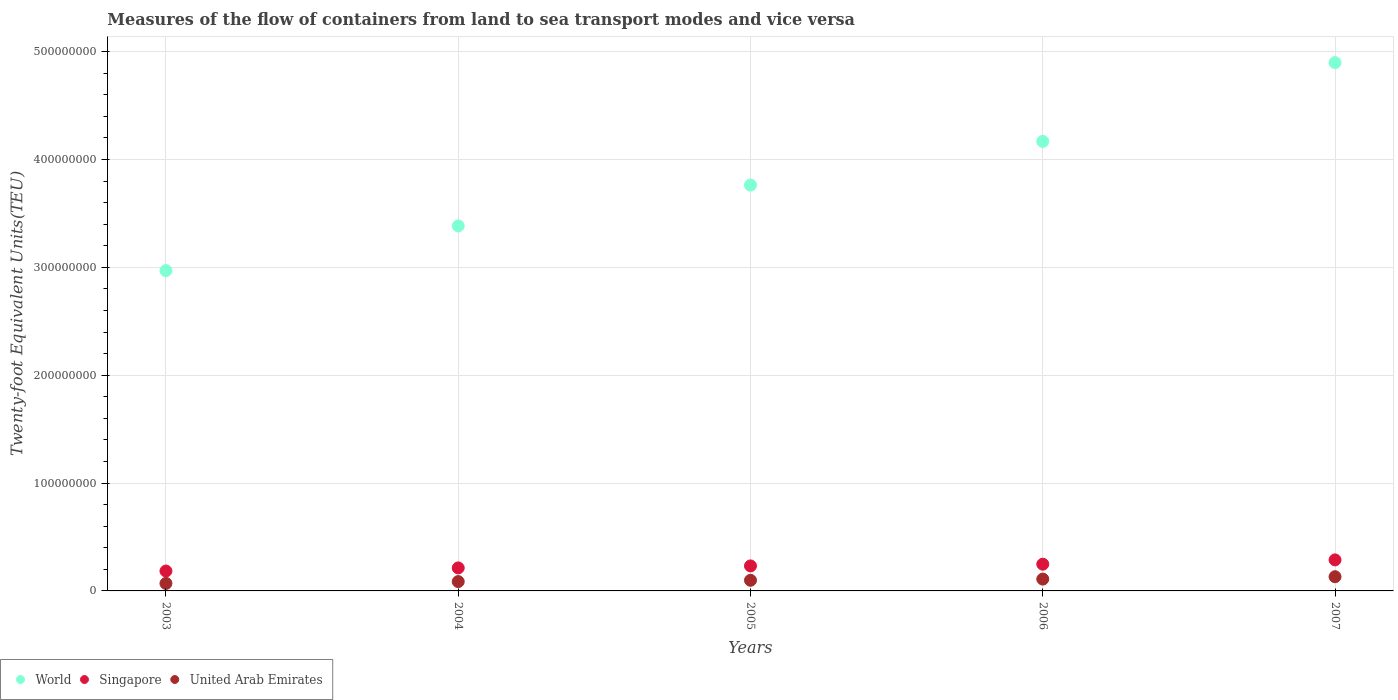Is the number of dotlines equal to the number of legend labels?
Make the answer very short. Yes. What is the container port traffic in World in 2006?
Make the answer very short. 4.17e+08. Across all years, what is the maximum container port traffic in Singapore?
Your response must be concise. 2.88e+07. Across all years, what is the minimum container port traffic in Singapore?
Make the answer very short. 1.84e+07. What is the total container port traffic in Singapore in the graph?
Your answer should be very brief. 1.17e+08. What is the difference between the container port traffic in World in 2004 and that in 2006?
Keep it short and to the point. -7.83e+07. What is the difference between the container port traffic in United Arab Emirates in 2004 and the container port traffic in World in 2007?
Give a very brief answer. -4.81e+08. What is the average container port traffic in World per year?
Give a very brief answer. 3.84e+08. In the year 2007, what is the difference between the container port traffic in Singapore and container port traffic in World?
Your answer should be very brief. -4.61e+08. What is the ratio of the container port traffic in World in 2004 to that in 2006?
Give a very brief answer. 0.81. What is the difference between the highest and the second highest container port traffic in Singapore?
Give a very brief answer. 3.98e+06. What is the difference between the highest and the lowest container port traffic in World?
Provide a short and direct response. 1.93e+08. In how many years, is the container port traffic in United Arab Emirates greater than the average container port traffic in United Arab Emirates taken over all years?
Make the answer very short. 2. Is the sum of the container port traffic in World in 2003 and 2004 greater than the maximum container port traffic in United Arab Emirates across all years?
Offer a terse response. Yes. Is it the case that in every year, the sum of the container port traffic in World and container port traffic in United Arab Emirates  is greater than the container port traffic in Singapore?
Your answer should be compact. Yes. How many years are there in the graph?
Make the answer very short. 5. Are the values on the major ticks of Y-axis written in scientific E-notation?
Keep it short and to the point. No. How are the legend labels stacked?
Make the answer very short. Horizontal. What is the title of the graph?
Ensure brevity in your answer.  Measures of the flow of containers from land to sea transport modes and vice versa. Does "Cameroon" appear as one of the legend labels in the graph?
Your answer should be very brief. No. What is the label or title of the Y-axis?
Your answer should be very brief. Twenty-foot Equivalent Units(TEU). What is the Twenty-foot Equivalent Units(TEU) in World in 2003?
Make the answer very short. 2.97e+08. What is the Twenty-foot Equivalent Units(TEU) of Singapore in 2003?
Keep it short and to the point. 1.84e+07. What is the Twenty-foot Equivalent Units(TEU) of United Arab Emirates in 2003?
Ensure brevity in your answer.  6.96e+06. What is the Twenty-foot Equivalent Units(TEU) in World in 2004?
Offer a very short reply. 3.38e+08. What is the Twenty-foot Equivalent Units(TEU) in Singapore in 2004?
Keep it short and to the point. 2.13e+07. What is the Twenty-foot Equivalent Units(TEU) in United Arab Emirates in 2004?
Make the answer very short. 8.66e+06. What is the Twenty-foot Equivalent Units(TEU) in World in 2005?
Keep it short and to the point. 3.76e+08. What is the Twenty-foot Equivalent Units(TEU) of Singapore in 2005?
Offer a terse response. 2.32e+07. What is the Twenty-foot Equivalent Units(TEU) of United Arab Emirates in 2005?
Give a very brief answer. 9.85e+06. What is the Twenty-foot Equivalent Units(TEU) of World in 2006?
Offer a very short reply. 4.17e+08. What is the Twenty-foot Equivalent Units(TEU) of Singapore in 2006?
Your answer should be very brief. 2.48e+07. What is the Twenty-foot Equivalent Units(TEU) in United Arab Emirates in 2006?
Provide a succinct answer. 1.10e+07. What is the Twenty-foot Equivalent Units(TEU) in World in 2007?
Ensure brevity in your answer.  4.90e+08. What is the Twenty-foot Equivalent Units(TEU) in Singapore in 2007?
Offer a terse response. 2.88e+07. What is the Twenty-foot Equivalent Units(TEU) of United Arab Emirates in 2007?
Your response must be concise. 1.32e+07. Across all years, what is the maximum Twenty-foot Equivalent Units(TEU) of World?
Make the answer very short. 4.90e+08. Across all years, what is the maximum Twenty-foot Equivalent Units(TEU) in Singapore?
Give a very brief answer. 2.88e+07. Across all years, what is the maximum Twenty-foot Equivalent Units(TEU) of United Arab Emirates?
Offer a very short reply. 1.32e+07. Across all years, what is the minimum Twenty-foot Equivalent Units(TEU) in World?
Provide a succinct answer. 2.97e+08. Across all years, what is the minimum Twenty-foot Equivalent Units(TEU) of Singapore?
Provide a succinct answer. 1.84e+07. Across all years, what is the minimum Twenty-foot Equivalent Units(TEU) in United Arab Emirates?
Make the answer very short. 6.96e+06. What is the total Twenty-foot Equivalent Units(TEU) of World in the graph?
Make the answer very short. 1.92e+09. What is the total Twenty-foot Equivalent Units(TEU) in Singapore in the graph?
Your answer should be compact. 1.17e+08. What is the total Twenty-foot Equivalent Units(TEU) of United Arab Emirates in the graph?
Give a very brief answer. 4.96e+07. What is the difference between the Twenty-foot Equivalent Units(TEU) in World in 2003 and that in 2004?
Provide a short and direct response. -4.14e+07. What is the difference between the Twenty-foot Equivalent Units(TEU) of Singapore in 2003 and that in 2004?
Provide a succinct answer. -2.89e+06. What is the difference between the Twenty-foot Equivalent Units(TEU) in United Arab Emirates in 2003 and that in 2004?
Give a very brief answer. -1.71e+06. What is the difference between the Twenty-foot Equivalent Units(TEU) in World in 2003 and that in 2005?
Your answer should be compact. -7.93e+07. What is the difference between the Twenty-foot Equivalent Units(TEU) in Singapore in 2003 and that in 2005?
Keep it short and to the point. -4.75e+06. What is the difference between the Twenty-foot Equivalent Units(TEU) in United Arab Emirates in 2003 and that in 2005?
Keep it short and to the point. -2.90e+06. What is the difference between the Twenty-foot Equivalent Units(TEU) in World in 2003 and that in 2006?
Your answer should be compact. -1.20e+08. What is the difference between the Twenty-foot Equivalent Units(TEU) of Singapore in 2003 and that in 2006?
Your answer should be very brief. -6.35e+06. What is the difference between the Twenty-foot Equivalent Units(TEU) of United Arab Emirates in 2003 and that in 2006?
Provide a short and direct response. -4.01e+06. What is the difference between the Twenty-foot Equivalent Units(TEU) in World in 2003 and that in 2007?
Offer a very short reply. -1.93e+08. What is the difference between the Twenty-foot Equivalent Units(TEU) in Singapore in 2003 and that in 2007?
Your answer should be very brief. -1.03e+07. What is the difference between the Twenty-foot Equivalent Units(TEU) of United Arab Emirates in 2003 and that in 2007?
Ensure brevity in your answer.  -6.23e+06. What is the difference between the Twenty-foot Equivalent Units(TEU) in World in 2004 and that in 2005?
Offer a very short reply. -3.78e+07. What is the difference between the Twenty-foot Equivalent Units(TEU) in Singapore in 2004 and that in 2005?
Your answer should be compact. -1.86e+06. What is the difference between the Twenty-foot Equivalent Units(TEU) in United Arab Emirates in 2004 and that in 2005?
Make the answer very short. -1.19e+06. What is the difference between the Twenty-foot Equivalent Units(TEU) of World in 2004 and that in 2006?
Keep it short and to the point. -7.83e+07. What is the difference between the Twenty-foot Equivalent Units(TEU) of Singapore in 2004 and that in 2006?
Your answer should be compact. -3.46e+06. What is the difference between the Twenty-foot Equivalent Units(TEU) in United Arab Emirates in 2004 and that in 2006?
Your answer should be very brief. -2.31e+06. What is the difference between the Twenty-foot Equivalent Units(TEU) in World in 2004 and that in 2007?
Give a very brief answer. -1.51e+08. What is the difference between the Twenty-foot Equivalent Units(TEU) of Singapore in 2004 and that in 2007?
Keep it short and to the point. -7.44e+06. What is the difference between the Twenty-foot Equivalent Units(TEU) in United Arab Emirates in 2004 and that in 2007?
Offer a terse response. -4.52e+06. What is the difference between the Twenty-foot Equivalent Units(TEU) of World in 2005 and that in 2006?
Provide a short and direct response. -4.05e+07. What is the difference between the Twenty-foot Equivalent Units(TEU) in Singapore in 2005 and that in 2006?
Your answer should be very brief. -1.60e+06. What is the difference between the Twenty-foot Equivalent Units(TEU) of United Arab Emirates in 2005 and that in 2006?
Provide a short and direct response. -1.12e+06. What is the difference between the Twenty-foot Equivalent Units(TEU) of World in 2005 and that in 2007?
Give a very brief answer. -1.14e+08. What is the difference between the Twenty-foot Equivalent Units(TEU) of Singapore in 2005 and that in 2007?
Provide a short and direct response. -5.58e+06. What is the difference between the Twenty-foot Equivalent Units(TEU) in United Arab Emirates in 2005 and that in 2007?
Give a very brief answer. -3.33e+06. What is the difference between the Twenty-foot Equivalent Units(TEU) in World in 2006 and that in 2007?
Provide a succinct answer. -7.31e+07. What is the difference between the Twenty-foot Equivalent Units(TEU) of Singapore in 2006 and that in 2007?
Offer a very short reply. -3.98e+06. What is the difference between the Twenty-foot Equivalent Units(TEU) of United Arab Emirates in 2006 and that in 2007?
Give a very brief answer. -2.22e+06. What is the difference between the Twenty-foot Equivalent Units(TEU) in World in 2003 and the Twenty-foot Equivalent Units(TEU) in Singapore in 2004?
Offer a terse response. 2.76e+08. What is the difference between the Twenty-foot Equivalent Units(TEU) in World in 2003 and the Twenty-foot Equivalent Units(TEU) in United Arab Emirates in 2004?
Your answer should be very brief. 2.88e+08. What is the difference between the Twenty-foot Equivalent Units(TEU) in Singapore in 2003 and the Twenty-foot Equivalent Units(TEU) in United Arab Emirates in 2004?
Offer a very short reply. 9.78e+06. What is the difference between the Twenty-foot Equivalent Units(TEU) of World in 2003 and the Twenty-foot Equivalent Units(TEU) of Singapore in 2005?
Ensure brevity in your answer.  2.74e+08. What is the difference between the Twenty-foot Equivalent Units(TEU) of World in 2003 and the Twenty-foot Equivalent Units(TEU) of United Arab Emirates in 2005?
Offer a very short reply. 2.87e+08. What is the difference between the Twenty-foot Equivalent Units(TEU) of Singapore in 2003 and the Twenty-foot Equivalent Units(TEU) of United Arab Emirates in 2005?
Keep it short and to the point. 8.59e+06. What is the difference between the Twenty-foot Equivalent Units(TEU) in World in 2003 and the Twenty-foot Equivalent Units(TEU) in Singapore in 2006?
Your answer should be compact. 2.72e+08. What is the difference between the Twenty-foot Equivalent Units(TEU) of World in 2003 and the Twenty-foot Equivalent Units(TEU) of United Arab Emirates in 2006?
Give a very brief answer. 2.86e+08. What is the difference between the Twenty-foot Equivalent Units(TEU) of Singapore in 2003 and the Twenty-foot Equivalent Units(TEU) of United Arab Emirates in 2006?
Offer a terse response. 7.47e+06. What is the difference between the Twenty-foot Equivalent Units(TEU) in World in 2003 and the Twenty-foot Equivalent Units(TEU) in Singapore in 2007?
Your answer should be compact. 2.68e+08. What is the difference between the Twenty-foot Equivalent Units(TEU) in World in 2003 and the Twenty-foot Equivalent Units(TEU) in United Arab Emirates in 2007?
Make the answer very short. 2.84e+08. What is the difference between the Twenty-foot Equivalent Units(TEU) of Singapore in 2003 and the Twenty-foot Equivalent Units(TEU) of United Arab Emirates in 2007?
Give a very brief answer. 5.26e+06. What is the difference between the Twenty-foot Equivalent Units(TEU) of World in 2004 and the Twenty-foot Equivalent Units(TEU) of Singapore in 2005?
Your answer should be compact. 3.15e+08. What is the difference between the Twenty-foot Equivalent Units(TEU) in World in 2004 and the Twenty-foot Equivalent Units(TEU) in United Arab Emirates in 2005?
Your response must be concise. 3.29e+08. What is the difference between the Twenty-foot Equivalent Units(TEU) in Singapore in 2004 and the Twenty-foot Equivalent Units(TEU) in United Arab Emirates in 2005?
Make the answer very short. 1.15e+07. What is the difference between the Twenty-foot Equivalent Units(TEU) of World in 2004 and the Twenty-foot Equivalent Units(TEU) of Singapore in 2006?
Provide a short and direct response. 3.14e+08. What is the difference between the Twenty-foot Equivalent Units(TEU) in World in 2004 and the Twenty-foot Equivalent Units(TEU) in United Arab Emirates in 2006?
Give a very brief answer. 3.27e+08. What is the difference between the Twenty-foot Equivalent Units(TEU) of Singapore in 2004 and the Twenty-foot Equivalent Units(TEU) of United Arab Emirates in 2006?
Make the answer very short. 1.04e+07. What is the difference between the Twenty-foot Equivalent Units(TEU) of World in 2004 and the Twenty-foot Equivalent Units(TEU) of Singapore in 2007?
Offer a very short reply. 3.10e+08. What is the difference between the Twenty-foot Equivalent Units(TEU) of World in 2004 and the Twenty-foot Equivalent Units(TEU) of United Arab Emirates in 2007?
Make the answer very short. 3.25e+08. What is the difference between the Twenty-foot Equivalent Units(TEU) in Singapore in 2004 and the Twenty-foot Equivalent Units(TEU) in United Arab Emirates in 2007?
Provide a succinct answer. 8.15e+06. What is the difference between the Twenty-foot Equivalent Units(TEU) in World in 2005 and the Twenty-foot Equivalent Units(TEU) in Singapore in 2006?
Provide a short and direct response. 3.51e+08. What is the difference between the Twenty-foot Equivalent Units(TEU) in World in 2005 and the Twenty-foot Equivalent Units(TEU) in United Arab Emirates in 2006?
Provide a short and direct response. 3.65e+08. What is the difference between the Twenty-foot Equivalent Units(TEU) in Singapore in 2005 and the Twenty-foot Equivalent Units(TEU) in United Arab Emirates in 2006?
Keep it short and to the point. 1.22e+07. What is the difference between the Twenty-foot Equivalent Units(TEU) in World in 2005 and the Twenty-foot Equivalent Units(TEU) in Singapore in 2007?
Offer a very short reply. 3.48e+08. What is the difference between the Twenty-foot Equivalent Units(TEU) of World in 2005 and the Twenty-foot Equivalent Units(TEU) of United Arab Emirates in 2007?
Your answer should be very brief. 3.63e+08. What is the difference between the Twenty-foot Equivalent Units(TEU) in Singapore in 2005 and the Twenty-foot Equivalent Units(TEU) in United Arab Emirates in 2007?
Your answer should be compact. 1.00e+07. What is the difference between the Twenty-foot Equivalent Units(TEU) of World in 2006 and the Twenty-foot Equivalent Units(TEU) of Singapore in 2007?
Your response must be concise. 3.88e+08. What is the difference between the Twenty-foot Equivalent Units(TEU) of World in 2006 and the Twenty-foot Equivalent Units(TEU) of United Arab Emirates in 2007?
Your response must be concise. 4.04e+08. What is the difference between the Twenty-foot Equivalent Units(TEU) in Singapore in 2006 and the Twenty-foot Equivalent Units(TEU) in United Arab Emirates in 2007?
Provide a succinct answer. 1.16e+07. What is the average Twenty-foot Equivalent Units(TEU) in World per year?
Ensure brevity in your answer.  3.84e+08. What is the average Twenty-foot Equivalent Units(TEU) in Singapore per year?
Offer a very short reply. 2.33e+07. What is the average Twenty-foot Equivalent Units(TEU) of United Arab Emirates per year?
Give a very brief answer. 9.92e+06. In the year 2003, what is the difference between the Twenty-foot Equivalent Units(TEU) in World and Twenty-foot Equivalent Units(TEU) in Singapore?
Provide a short and direct response. 2.79e+08. In the year 2003, what is the difference between the Twenty-foot Equivalent Units(TEU) in World and Twenty-foot Equivalent Units(TEU) in United Arab Emirates?
Offer a very short reply. 2.90e+08. In the year 2003, what is the difference between the Twenty-foot Equivalent Units(TEU) in Singapore and Twenty-foot Equivalent Units(TEU) in United Arab Emirates?
Your response must be concise. 1.15e+07. In the year 2004, what is the difference between the Twenty-foot Equivalent Units(TEU) of World and Twenty-foot Equivalent Units(TEU) of Singapore?
Offer a very short reply. 3.17e+08. In the year 2004, what is the difference between the Twenty-foot Equivalent Units(TEU) in World and Twenty-foot Equivalent Units(TEU) in United Arab Emirates?
Ensure brevity in your answer.  3.30e+08. In the year 2004, what is the difference between the Twenty-foot Equivalent Units(TEU) of Singapore and Twenty-foot Equivalent Units(TEU) of United Arab Emirates?
Offer a terse response. 1.27e+07. In the year 2005, what is the difference between the Twenty-foot Equivalent Units(TEU) in World and Twenty-foot Equivalent Units(TEU) in Singapore?
Provide a succinct answer. 3.53e+08. In the year 2005, what is the difference between the Twenty-foot Equivalent Units(TEU) of World and Twenty-foot Equivalent Units(TEU) of United Arab Emirates?
Ensure brevity in your answer.  3.66e+08. In the year 2005, what is the difference between the Twenty-foot Equivalent Units(TEU) in Singapore and Twenty-foot Equivalent Units(TEU) in United Arab Emirates?
Offer a very short reply. 1.33e+07. In the year 2006, what is the difference between the Twenty-foot Equivalent Units(TEU) of World and Twenty-foot Equivalent Units(TEU) of Singapore?
Your answer should be compact. 3.92e+08. In the year 2006, what is the difference between the Twenty-foot Equivalent Units(TEU) of World and Twenty-foot Equivalent Units(TEU) of United Arab Emirates?
Your answer should be very brief. 4.06e+08. In the year 2006, what is the difference between the Twenty-foot Equivalent Units(TEU) in Singapore and Twenty-foot Equivalent Units(TEU) in United Arab Emirates?
Your answer should be compact. 1.38e+07. In the year 2007, what is the difference between the Twenty-foot Equivalent Units(TEU) of World and Twenty-foot Equivalent Units(TEU) of Singapore?
Give a very brief answer. 4.61e+08. In the year 2007, what is the difference between the Twenty-foot Equivalent Units(TEU) of World and Twenty-foot Equivalent Units(TEU) of United Arab Emirates?
Make the answer very short. 4.77e+08. In the year 2007, what is the difference between the Twenty-foot Equivalent Units(TEU) in Singapore and Twenty-foot Equivalent Units(TEU) in United Arab Emirates?
Offer a very short reply. 1.56e+07. What is the ratio of the Twenty-foot Equivalent Units(TEU) of World in 2003 to that in 2004?
Offer a terse response. 0.88. What is the ratio of the Twenty-foot Equivalent Units(TEU) of Singapore in 2003 to that in 2004?
Make the answer very short. 0.86. What is the ratio of the Twenty-foot Equivalent Units(TEU) of United Arab Emirates in 2003 to that in 2004?
Provide a short and direct response. 0.8. What is the ratio of the Twenty-foot Equivalent Units(TEU) of World in 2003 to that in 2005?
Your answer should be very brief. 0.79. What is the ratio of the Twenty-foot Equivalent Units(TEU) in Singapore in 2003 to that in 2005?
Your answer should be very brief. 0.8. What is the ratio of the Twenty-foot Equivalent Units(TEU) of United Arab Emirates in 2003 to that in 2005?
Ensure brevity in your answer.  0.71. What is the ratio of the Twenty-foot Equivalent Units(TEU) in World in 2003 to that in 2006?
Your answer should be compact. 0.71. What is the ratio of the Twenty-foot Equivalent Units(TEU) of Singapore in 2003 to that in 2006?
Your response must be concise. 0.74. What is the ratio of the Twenty-foot Equivalent Units(TEU) in United Arab Emirates in 2003 to that in 2006?
Keep it short and to the point. 0.63. What is the ratio of the Twenty-foot Equivalent Units(TEU) in World in 2003 to that in 2007?
Your answer should be very brief. 0.61. What is the ratio of the Twenty-foot Equivalent Units(TEU) of Singapore in 2003 to that in 2007?
Keep it short and to the point. 0.64. What is the ratio of the Twenty-foot Equivalent Units(TEU) in United Arab Emirates in 2003 to that in 2007?
Give a very brief answer. 0.53. What is the ratio of the Twenty-foot Equivalent Units(TEU) of World in 2004 to that in 2005?
Your answer should be compact. 0.9. What is the ratio of the Twenty-foot Equivalent Units(TEU) in Singapore in 2004 to that in 2005?
Make the answer very short. 0.92. What is the ratio of the Twenty-foot Equivalent Units(TEU) in United Arab Emirates in 2004 to that in 2005?
Ensure brevity in your answer.  0.88. What is the ratio of the Twenty-foot Equivalent Units(TEU) in World in 2004 to that in 2006?
Offer a terse response. 0.81. What is the ratio of the Twenty-foot Equivalent Units(TEU) in Singapore in 2004 to that in 2006?
Provide a succinct answer. 0.86. What is the ratio of the Twenty-foot Equivalent Units(TEU) of United Arab Emirates in 2004 to that in 2006?
Offer a terse response. 0.79. What is the ratio of the Twenty-foot Equivalent Units(TEU) of World in 2004 to that in 2007?
Your response must be concise. 0.69. What is the ratio of the Twenty-foot Equivalent Units(TEU) of Singapore in 2004 to that in 2007?
Offer a very short reply. 0.74. What is the ratio of the Twenty-foot Equivalent Units(TEU) in United Arab Emirates in 2004 to that in 2007?
Give a very brief answer. 0.66. What is the ratio of the Twenty-foot Equivalent Units(TEU) in World in 2005 to that in 2006?
Give a very brief answer. 0.9. What is the ratio of the Twenty-foot Equivalent Units(TEU) in Singapore in 2005 to that in 2006?
Your answer should be very brief. 0.94. What is the ratio of the Twenty-foot Equivalent Units(TEU) of United Arab Emirates in 2005 to that in 2006?
Make the answer very short. 0.9. What is the ratio of the Twenty-foot Equivalent Units(TEU) of World in 2005 to that in 2007?
Provide a short and direct response. 0.77. What is the ratio of the Twenty-foot Equivalent Units(TEU) in Singapore in 2005 to that in 2007?
Provide a short and direct response. 0.81. What is the ratio of the Twenty-foot Equivalent Units(TEU) in United Arab Emirates in 2005 to that in 2007?
Offer a very short reply. 0.75. What is the ratio of the Twenty-foot Equivalent Units(TEU) in World in 2006 to that in 2007?
Provide a succinct answer. 0.85. What is the ratio of the Twenty-foot Equivalent Units(TEU) of Singapore in 2006 to that in 2007?
Your response must be concise. 0.86. What is the ratio of the Twenty-foot Equivalent Units(TEU) in United Arab Emirates in 2006 to that in 2007?
Make the answer very short. 0.83. What is the difference between the highest and the second highest Twenty-foot Equivalent Units(TEU) in World?
Your answer should be compact. 7.31e+07. What is the difference between the highest and the second highest Twenty-foot Equivalent Units(TEU) in Singapore?
Your answer should be compact. 3.98e+06. What is the difference between the highest and the second highest Twenty-foot Equivalent Units(TEU) in United Arab Emirates?
Your response must be concise. 2.22e+06. What is the difference between the highest and the lowest Twenty-foot Equivalent Units(TEU) of World?
Your response must be concise. 1.93e+08. What is the difference between the highest and the lowest Twenty-foot Equivalent Units(TEU) in Singapore?
Your response must be concise. 1.03e+07. What is the difference between the highest and the lowest Twenty-foot Equivalent Units(TEU) in United Arab Emirates?
Give a very brief answer. 6.23e+06. 